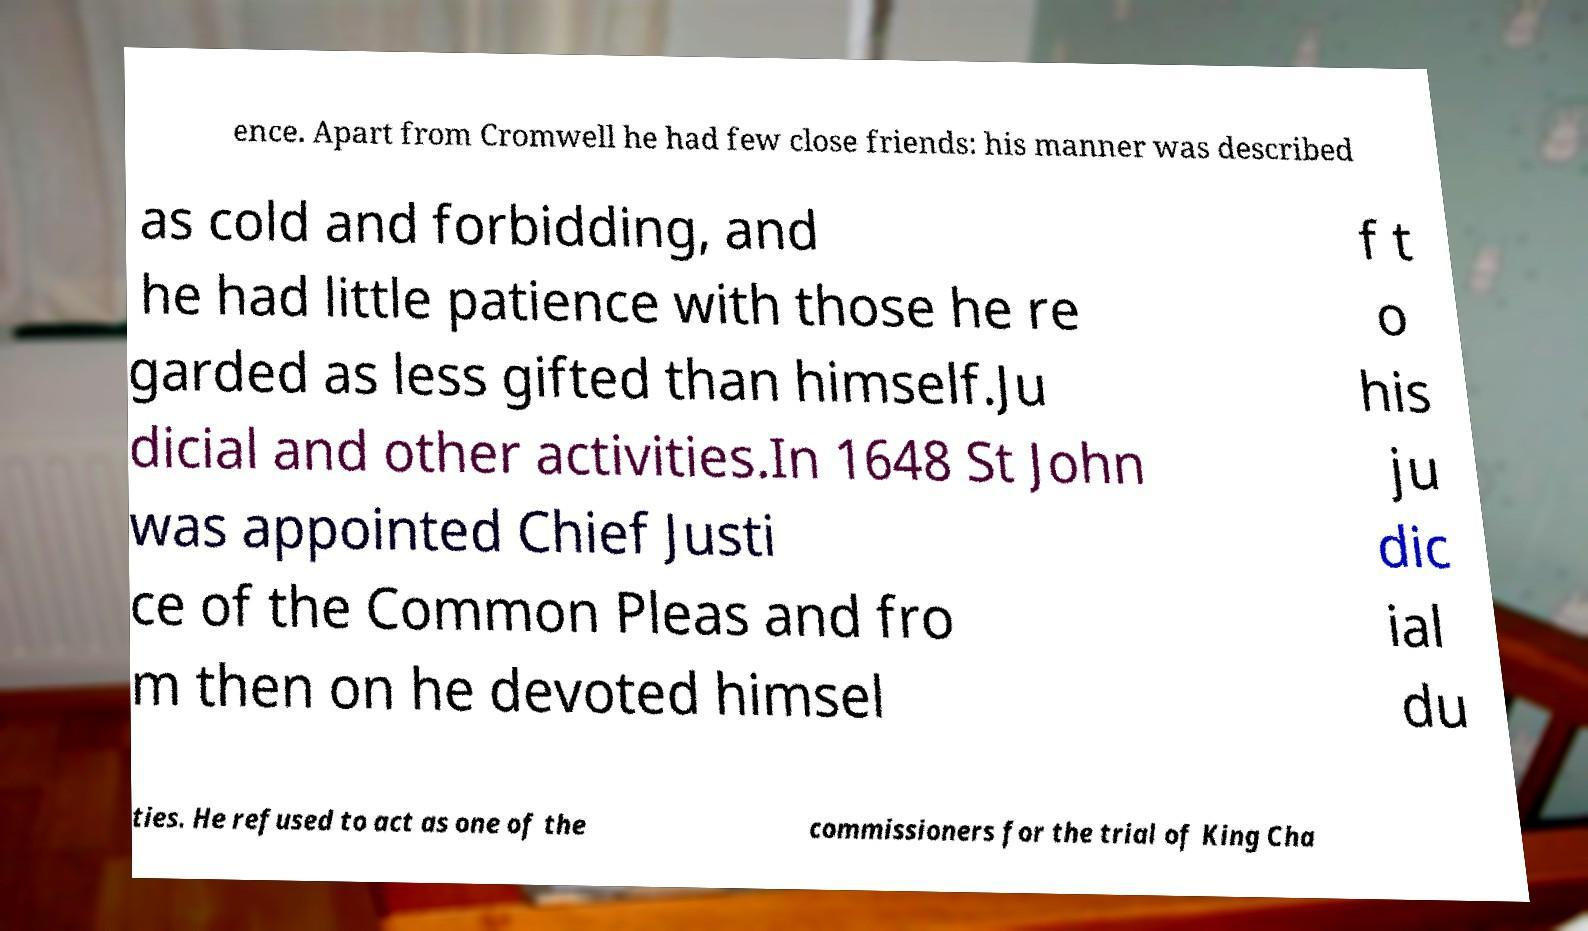Could you assist in decoding the text presented in this image and type it out clearly? ence. Apart from Cromwell he had few close friends: his manner was described as cold and forbidding, and he had little patience with those he re garded as less gifted than himself.Ju dicial and other activities.In 1648 St John was appointed Chief Justi ce of the Common Pleas and fro m then on he devoted himsel f t o his ju dic ial du ties. He refused to act as one of the commissioners for the trial of King Cha 